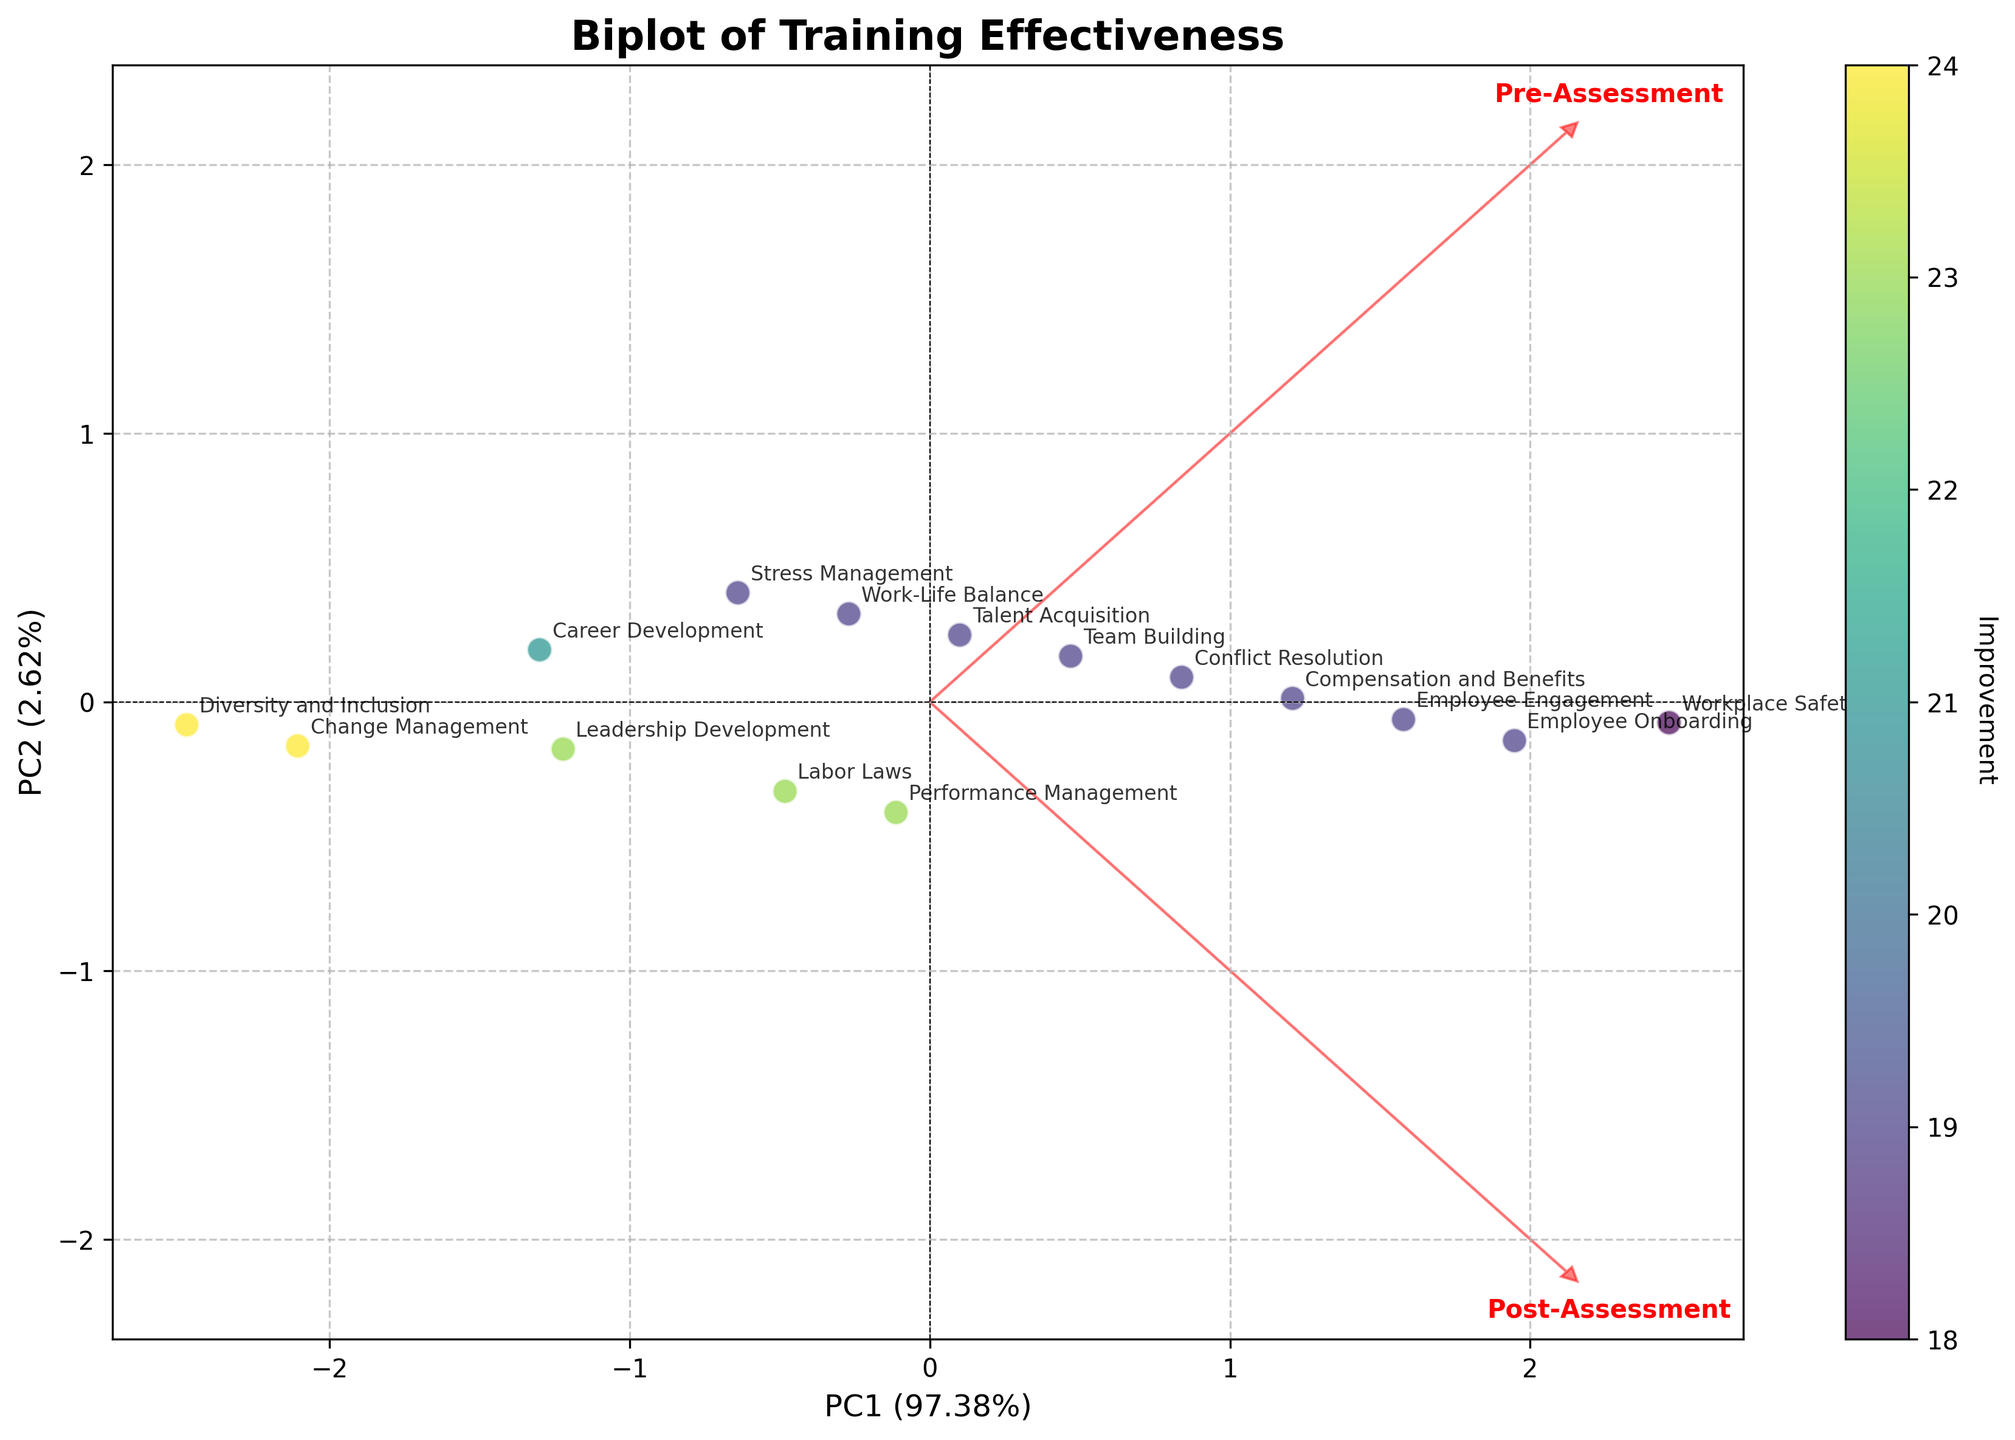What is the title of the figure? The title of the figure is presented at the top of the plot, typically in bold and larger font than the other text elements.
Answer: Biplot of Training Effectiveness How many data points are plotted in the figure? Each data point represents a topic and there are 15 topics listed in the data provided, so there should be 15 plotted points.
Answer: 15 Which HR topic shows the greatest improvement in training? Look for the point with the highest color intensity, which represents the greatest improvement according to the colorbar.
Answer: Diversity and Inclusion (24 improvement) What do the arrows represent in the biplot? The arrows represent the feature vectors of the pre- and post-assessment scores, showing their direction and correlation with the principal components.
Answer: Feature vectors of pre- and post-assessment scores Which principal component explains the most variance? Check the percentages in the x-axis and y-axis labels, indicating the variance each principal component explains.
Answer: PC1 Compare the pre- and post-assessment correlation with the first principal component. Observe the direction and length of the arrows for pre- and post-assessment along the PC1 axis. Longer arrows indicate a stronger correlation.
Answer: Both are strongly correlated with PC1 Is there any topic that has a low improvement but a high post-assessment score? Identify points with lighter color (lower improvement) that are situated far along the post-assessment vector direction.
Answer: Workplace Safety (18 improvement) Which topics are most similar in terms of training effectiveness based on the biplot? Look for points that are close to each other and have similar colors, indicating similar pre- and post-assessment performance and improvement scores.
Answer: Employee Engagement and Compensation and Benefits What percentage of variance is explained by the second principal component? Examine the y-axis label for the percentage value associated with PC2.
Answer: Around 30% Based on the biplot, which principal component (PC1 or PC2) reflects a stronger differentiation between pre- and post-assessment scores? Compare the arrow lengths and directions relative to PC1 and PC2; a longer arrow in one direction indicates stronger differentiation.
Answer: PC1 